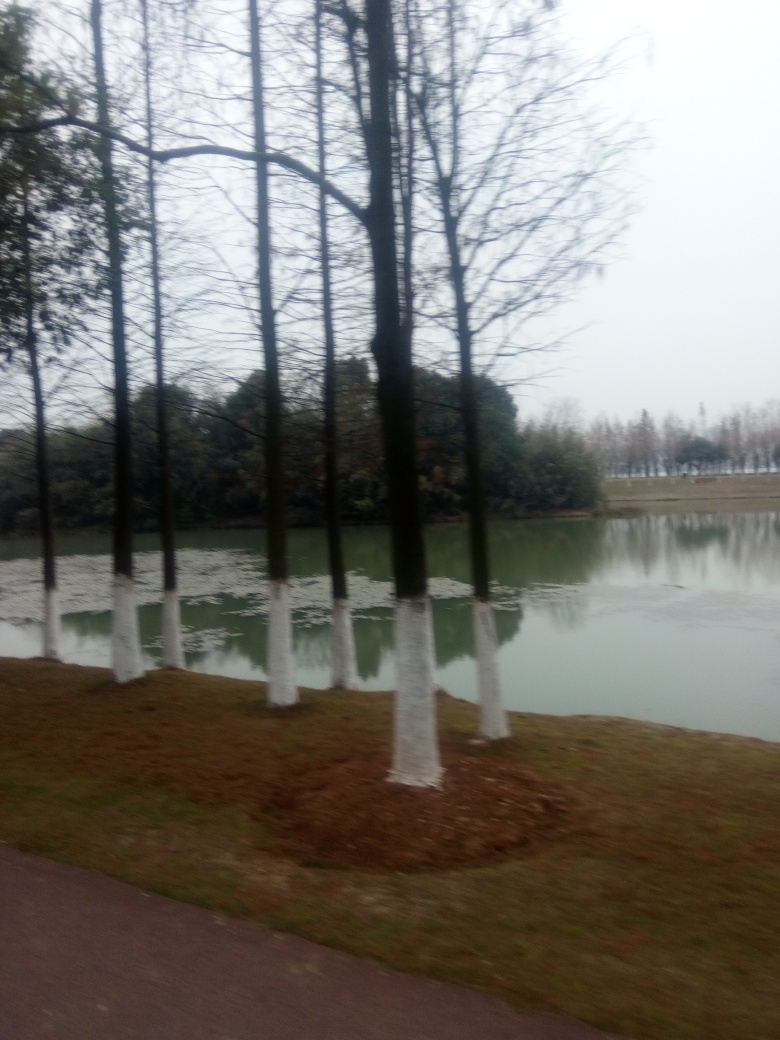Are the trees in the image deciduous or evergreen? The trees in the image appear to be deciduous as they have no leaves, which suggests they shed their foliage seasonally. 